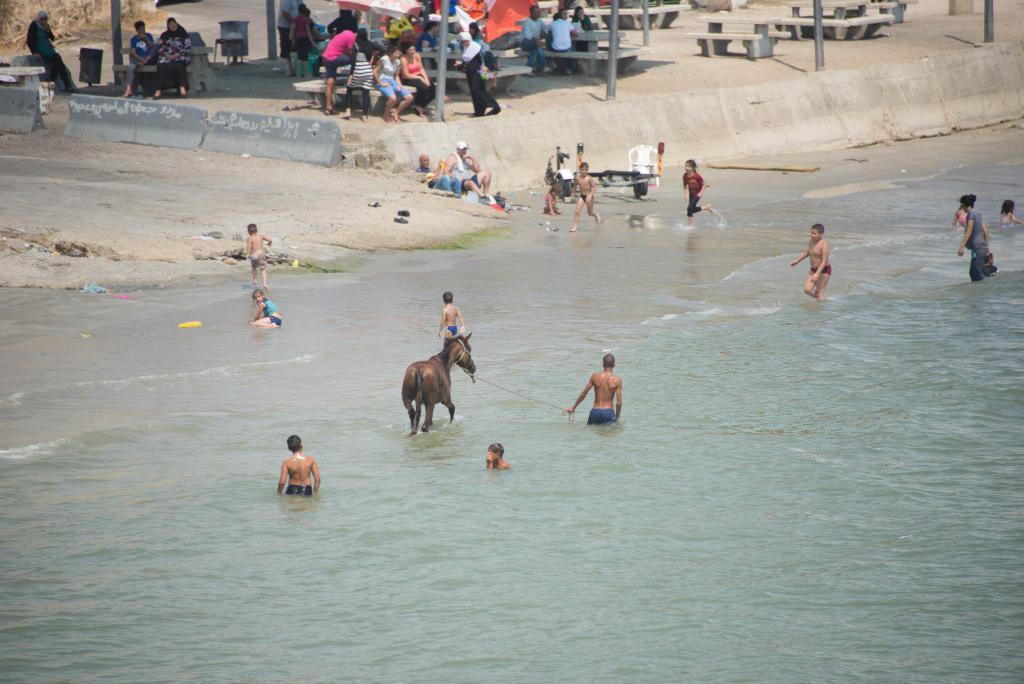Describe this image in one or two sentences. In this picture we can see there are groups of people and some objects. Some people are sitting on the benches and some people are in the water. There is a horse in the water. In the top left corner of the image, there are concrete barriers. 